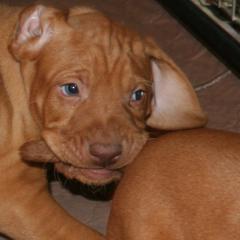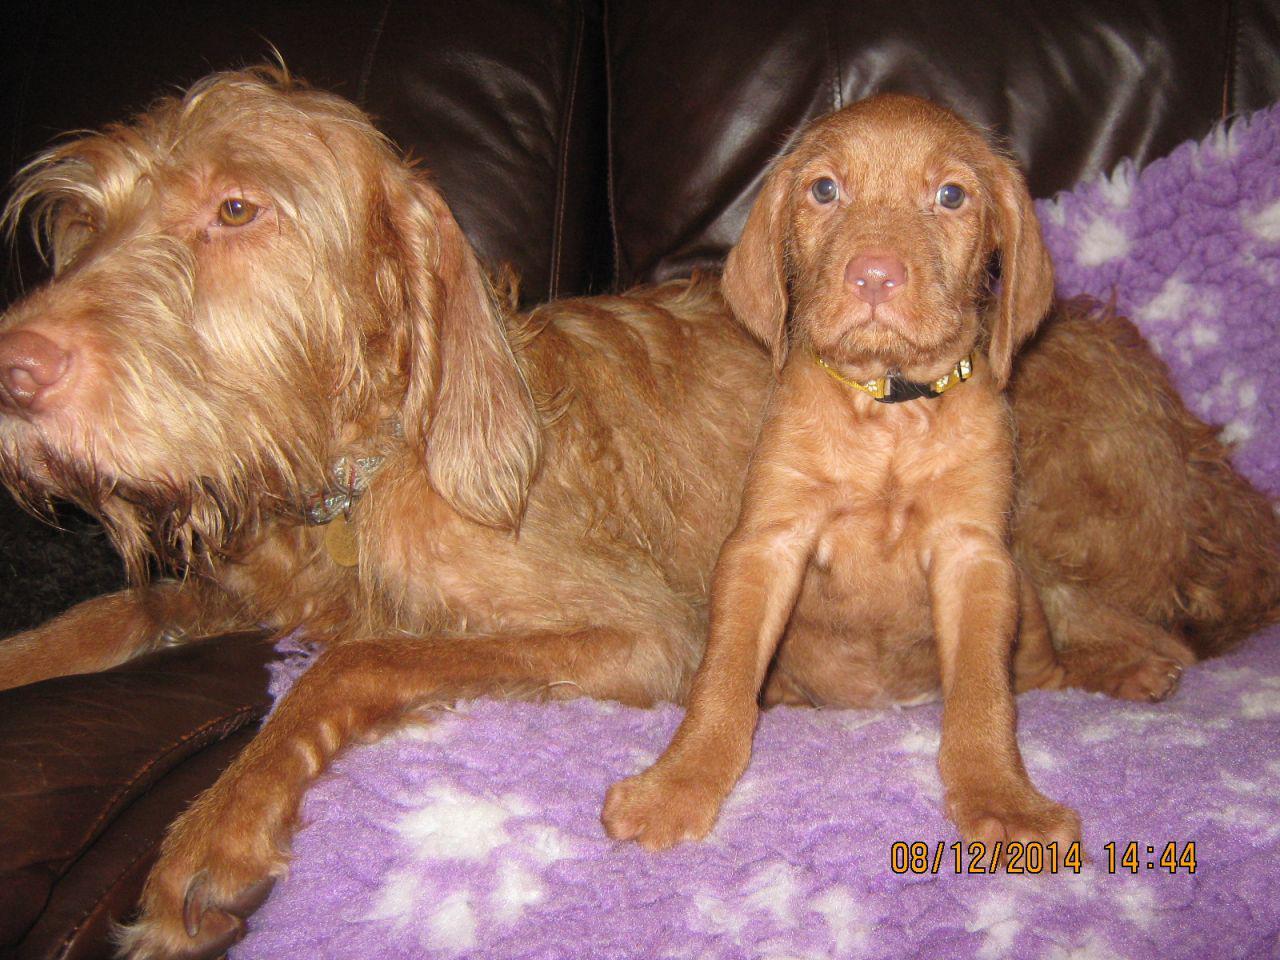The first image is the image on the left, the second image is the image on the right. Considering the images on both sides, is "Each image contains one red-orange dog, each dog has short hair and a closed mouth, and one image shows a dog with an upright head facing forward." valid? Answer yes or no. No. The first image is the image on the left, the second image is the image on the right. Given the left and right images, does the statement "There are two dogs." hold true? Answer yes or no. No. 